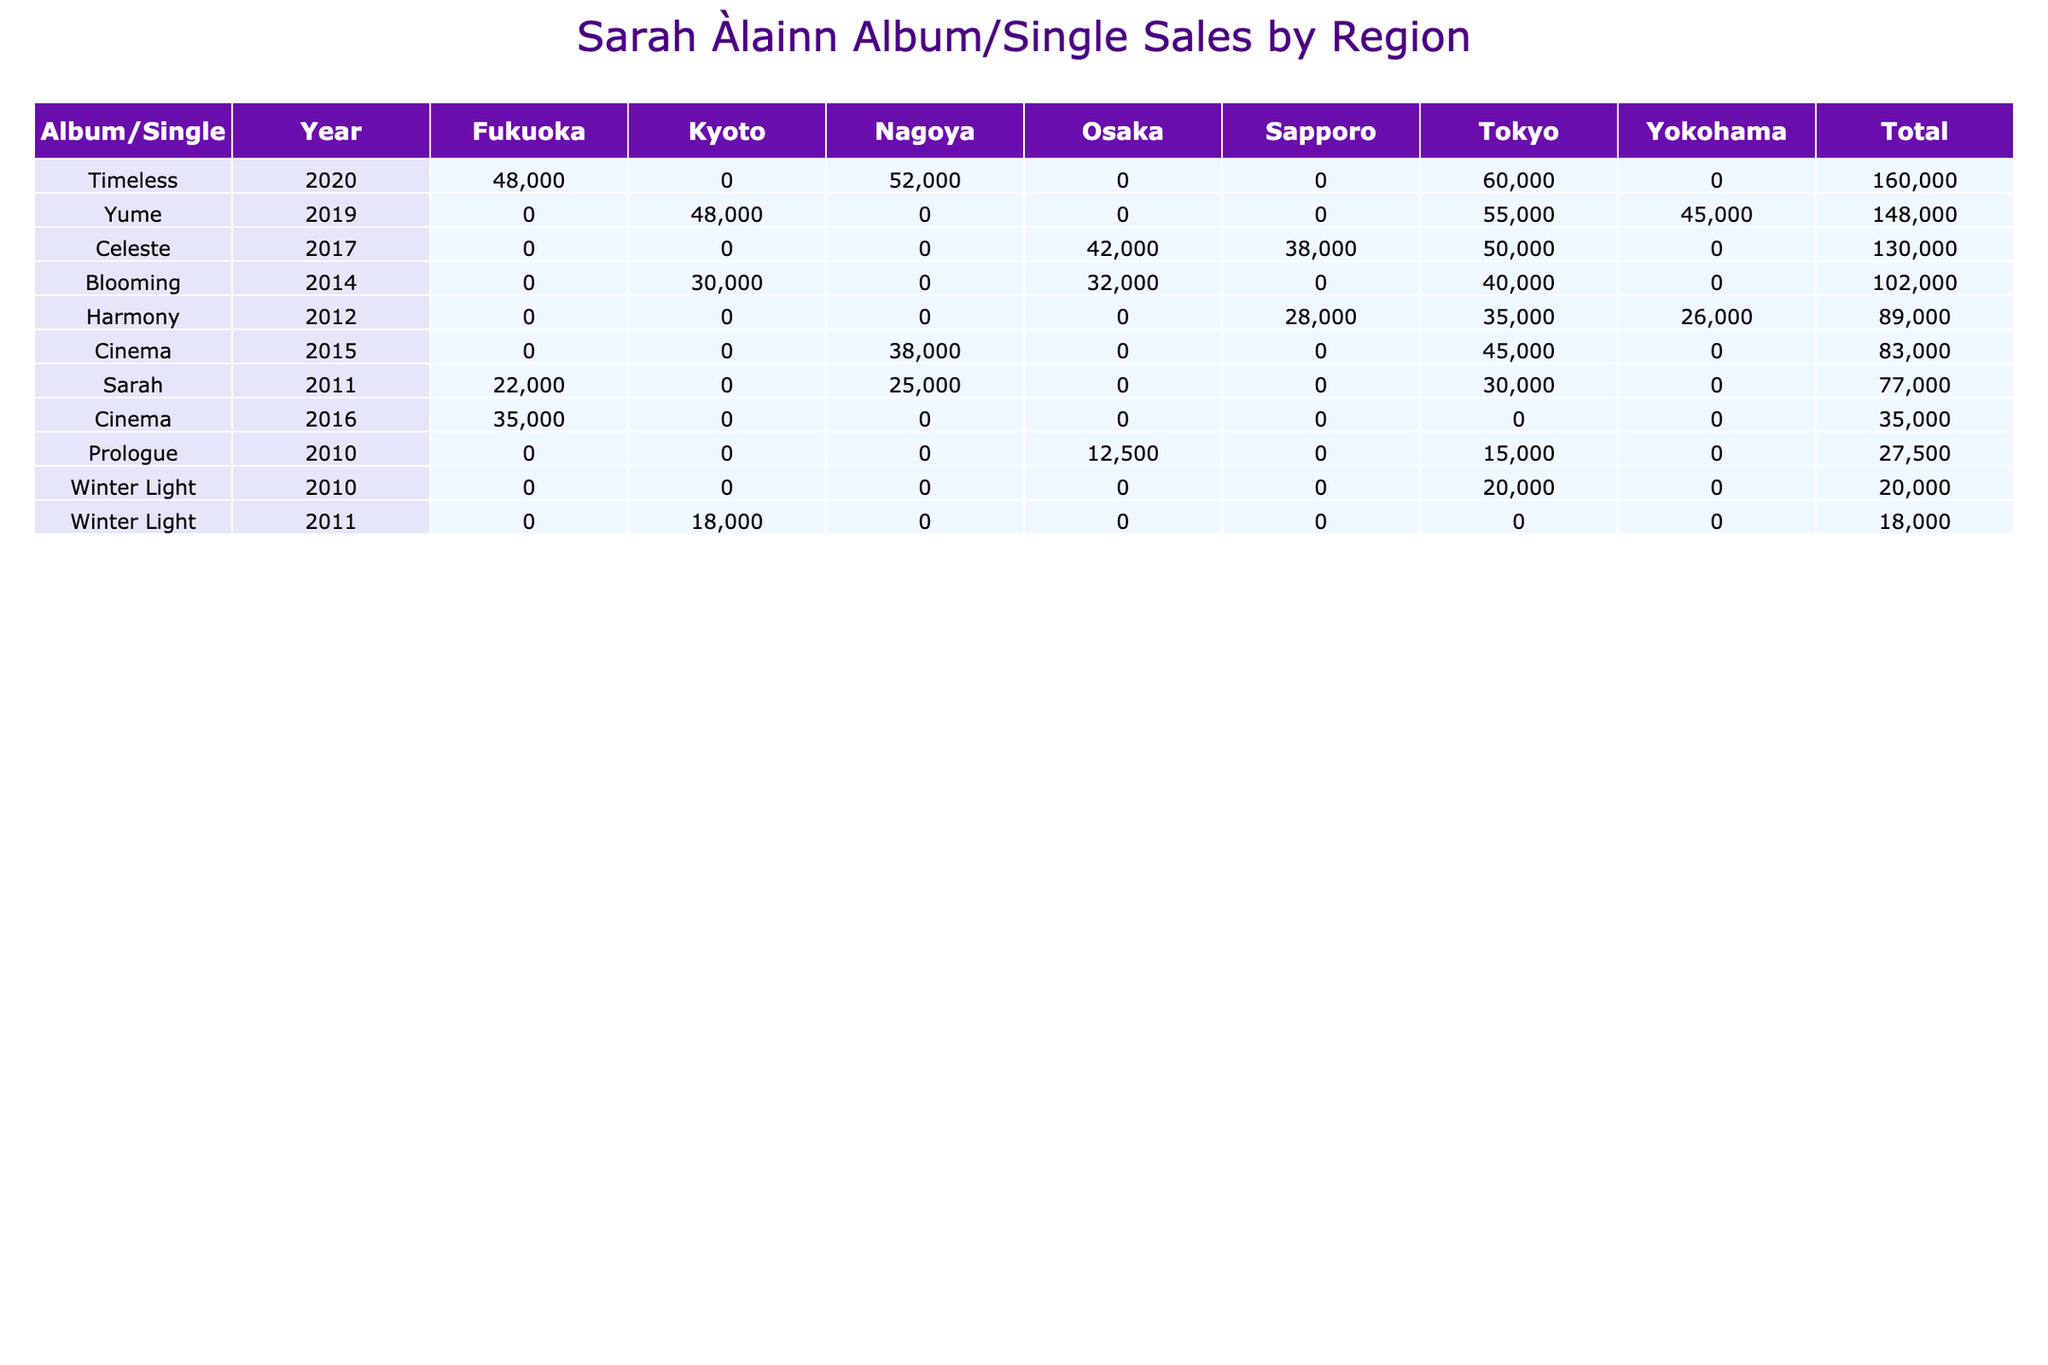What is the total sales for the album "Yume"? To find the total sales for "Yume," I look at the rows corresponding to "Yume" in the table. The sales figures are 55000 (February), 48000 (March), and 45000 (April). Summing these gives 55000 + 48000 + 45000 = 148000.
Answer: 148000 Which region generated the highest sales for the album "Cinema"? For "Cinema," the sales figures are 45000 (Tokyo), 38000 (Nagoya), and 35000 (Fukuoka). Out of these, Tokyo has the highest sales at 45000.
Answer: Tokyo Was there any album released in 2012? Checking the Year column, I see that there is an album titled "Harmony" released in 2012, with sales recorded in Tokyo, Sapporo, and Yokohama.
Answer: Yes What is the average sales amount for the album "Celeste"? For "Celeste," the sales are 50000 (May), 42000 (June), and 38000 (July). First, I sum these sales: 50000 + 42000 + 38000 = 130000. Then I divide by the number of months (3) to get the average: 130000 / 3 = 43333.33. Rounding gives approximately 43333.
Answer: 43333 In which month did the album "Blooming" have the lowest sales? Looking at the sales for "Blooming," I see the sales figures are 40000 (April), 32000 (May), and 30000 (June). June has the lowest sales at 30000.
Answer: June What is the total sales across all albums for the year 2020? To find the total sales for 2020, I look at the sales figures for that year: "Timeless" had sales of 60000 (October), 52000 (November), and 48000 (December). Summing these gives 60000 + 52000 + 48000 = 160000.
Answer: 160000 Did Sarah Àlainn's album "Prologue" sell more in February or January of 2010? For "Prologue," the sales are 12500 (February) and 15000 (January). Comparatively, January sales were higher at 15000.
Answer: January What were the total sales in Osaka across all albums? For Osaka, I check the sales from the table. The relevant amounts are 12500 (Prologue), 32000 (Blooming), and 42000 (Celeste). Totaling these gives 12500 + 32000 + 42000 = 86500.
Answer: 86500 